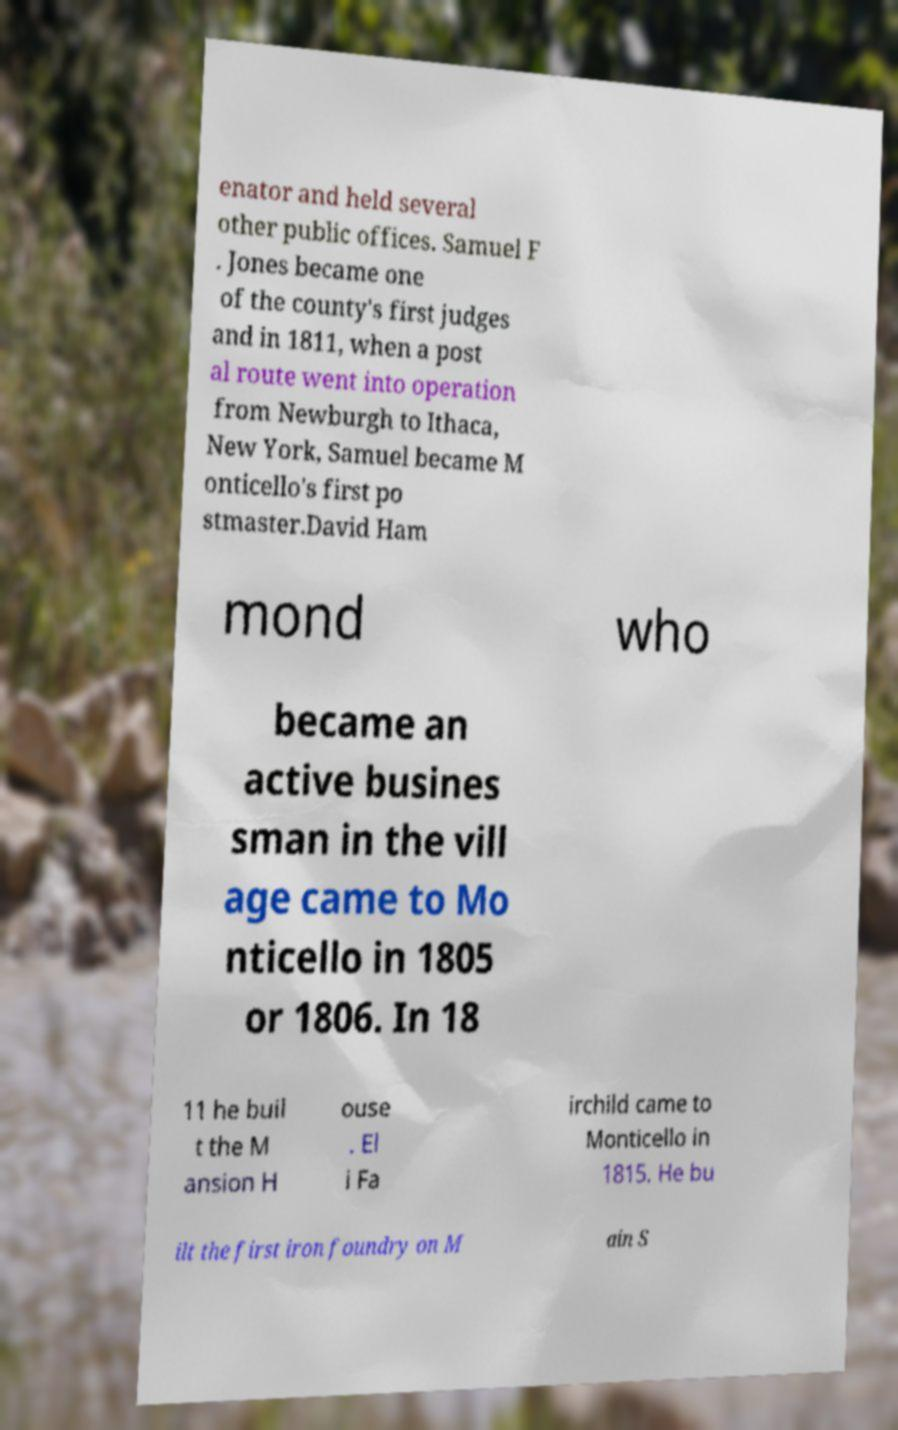Can you accurately transcribe the text from the provided image for me? enator and held several other public offices. Samuel F . Jones became one of the county's first judges and in 1811, when a post al route went into operation from Newburgh to Ithaca, New York, Samuel became M onticello's first po stmaster.David Ham mond who became an active busines sman in the vill age came to Mo nticello in 1805 or 1806. In 18 11 he buil t the M ansion H ouse . El i Fa irchild came to Monticello in 1815. He bu ilt the first iron foundry on M ain S 